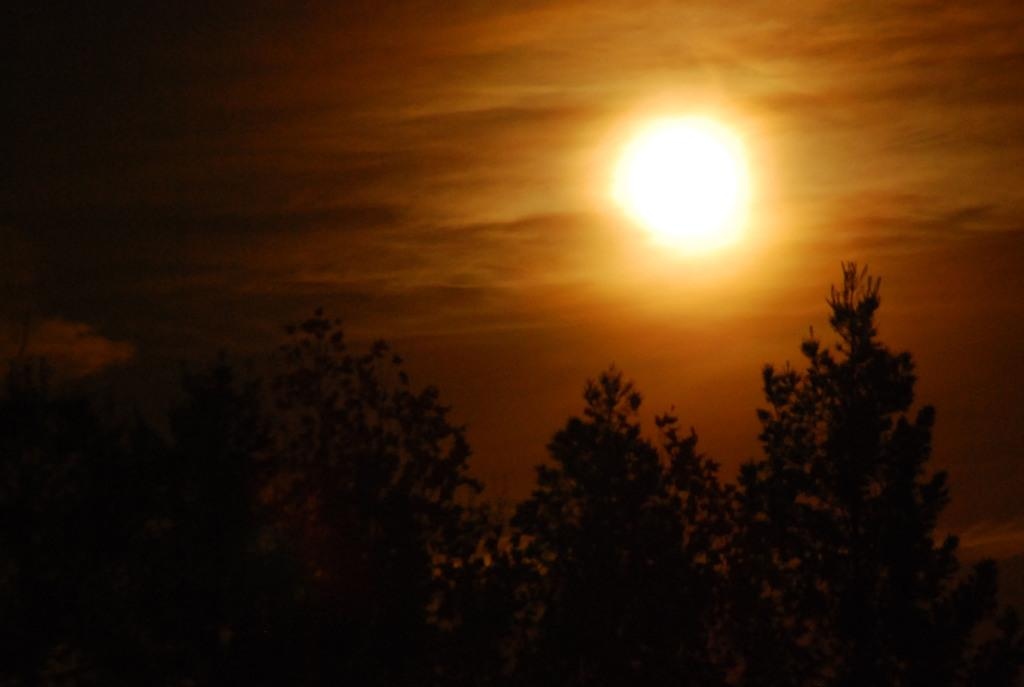What type of natural elements can be seen in the image? There are many trees in the image. What celestial body is visible in the background of the image? The sun is visible in the background of the image. What else can be seen in the background of the image? The sky is visible in the background of the image. What type of debt is being discussed in the image? There is no mention of debt in the image; it features trees, the sun, and the sky. What type of watch is visible on someone's wrist in the image? There are no people or watches present in the image. 